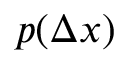<formula> <loc_0><loc_0><loc_500><loc_500>p ( \Delta x )</formula> 